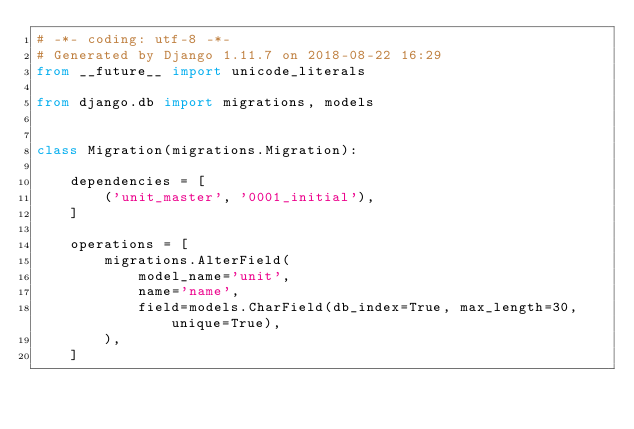<code> <loc_0><loc_0><loc_500><loc_500><_Python_># -*- coding: utf-8 -*-
# Generated by Django 1.11.7 on 2018-08-22 16:29
from __future__ import unicode_literals

from django.db import migrations, models


class Migration(migrations.Migration):

    dependencies = [
        ('unit_master', '0001_initial'),
    ]

    operations = [
        migrations.AlterField(
            model_name='unit',
            name='name',
            field=models.CharField(db_index=True, max_length=30, unique=True),
        ),
    ]
</code> 